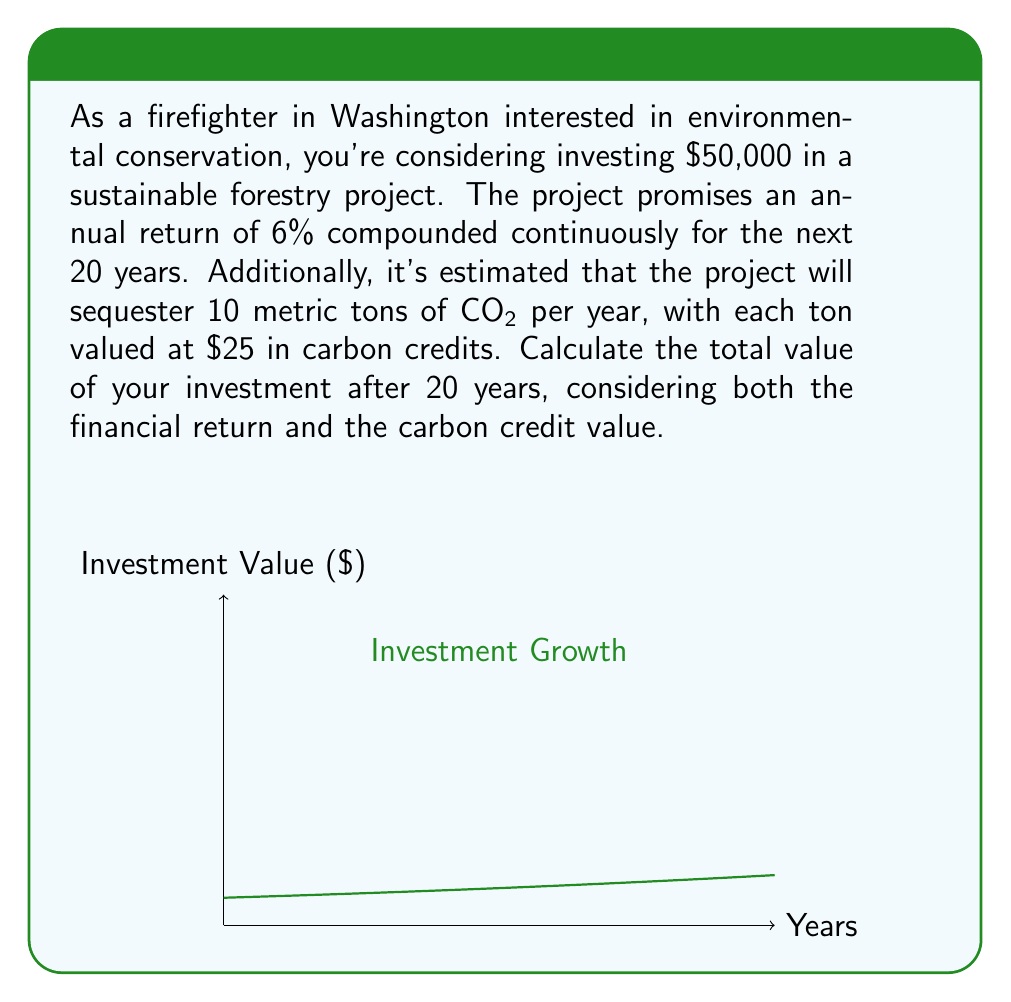Help me with this question. Let's break this problem down into steps:

1) First, let's calculate the value of the financial investment after 20 years:
   The formula for continuous compound interest is:
   $$A = P \cdot e^{rt}$$
   Where:
   $A$ = final amount
   $P$ = principal (initial investment)
   $r$ = annual interest rate
   $t$ = time in years
   $e$ = Euler's number (approximately 2.71828)

   Plugging in our values:
   $$A = 50000 \cdot e^{0.06 \cdot 20} = 50000 \cdot e^{1.2} \approx 165,727.52$$

2) Now, let's calculate the value of the carbon credits:
   Annual carbon sequestration: 10 metric tons
   Value per ton: $25
   Annual value: $10 \cdot $25 = $250
   Total value over 20 years: $250 \cdot 20 = $5,000

3) To get the total value, we add the financial investment return and the carbon credit value:
   $165,727.52 + $5,000 = $170,727.52
Answer: $170,727.52 